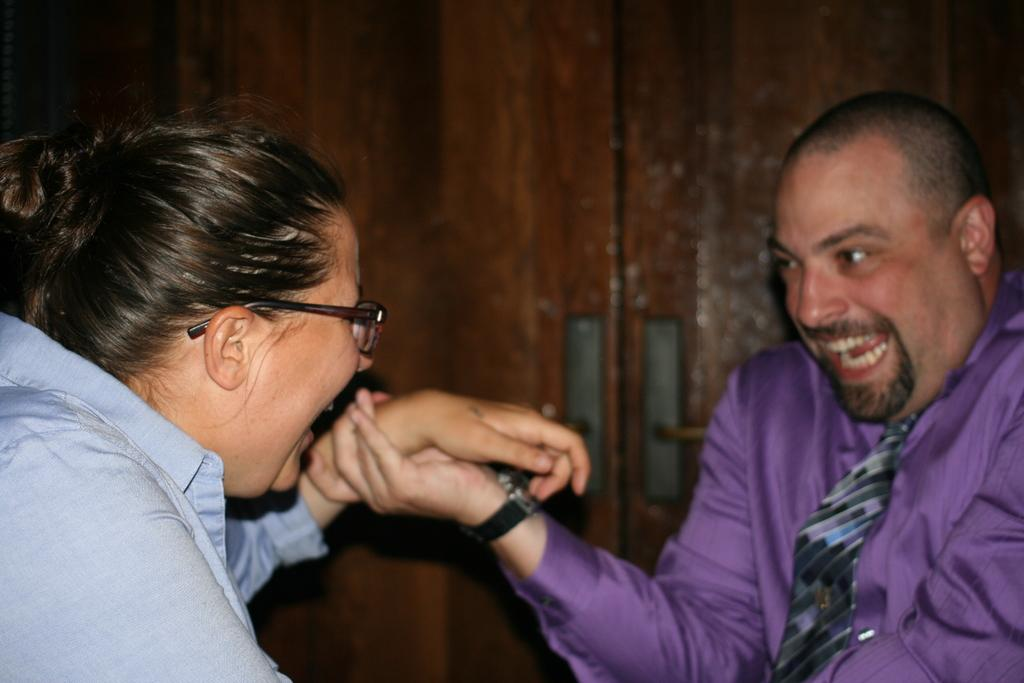Who are the two people in the foreground of the image? There is a woman and a man in the foreground of the image. What is the man doing with the woman? The man is holding the hand of the woman. What can be seen in the background of the image? There appears to be a wooden door in the background of the image. What type of doctor is sitting on the sofa in the image? There is no doctor or sofa present in the image. 